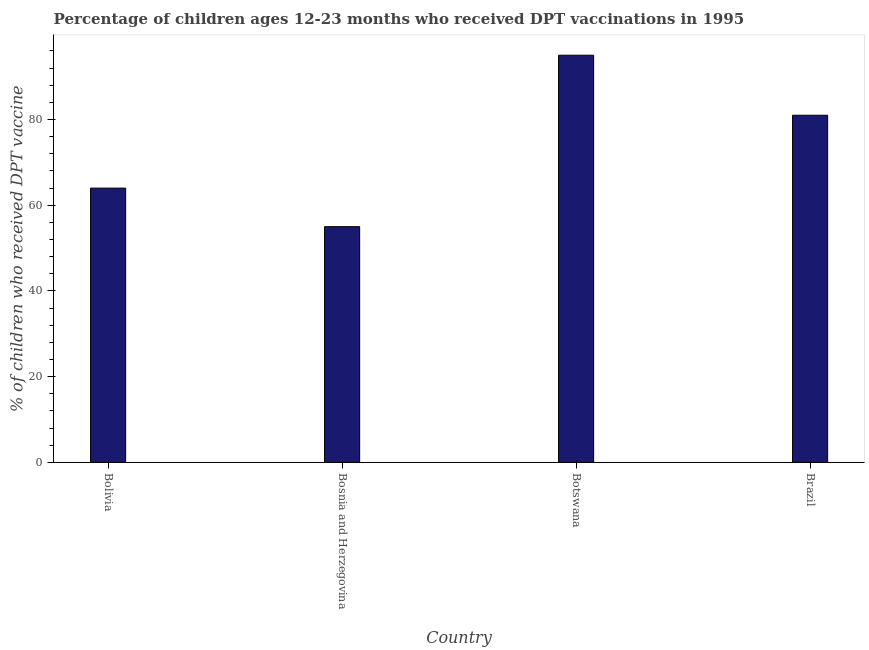What is the title of the graph?
Your answer should be compact. Percentage of children ages 12-23 months who received DPT vaccinations in 1995. What is the label or title of the X-axis?
Give a very brief answer. Country. What is the label or title of the Y-axis?
Ensure brevity in your answer.  % of children who received DPT vaccine. What is the percentage of children who received dpt vaccine in Bosnia and Herzegovina?
Your answer should be very brief. 55. Across all countries, what is the minimum percentage of children who received dpt vaccine?
Make the answer very short. 55. In which country was the percentage of children who received dpt vaccine maximum?
Offer a terse response. Botswana. In which country was the percentage of children who received dpt vaccine minimum?
Your answer should be very brief. Bosnia and Herzegovina. What is the sum of the percentage of children who received dpt vaccine?
Keep it short and to the point. 295. What is the difference between the percentage of children who received dpt vaccine in Bosnia and Herzegovina and Brazil?
Offer a terse response. -26. What is the average percentage of children who received dpt vaccine per country?
Provide a short and direct response. 73.75. What is the median percentage of children who received dpt vaccine?
Give a very brief answer. 72.5. What is the ratio of the percentage of children who received dpt vaccine in Bolivia to that in Bosnia and Herzegovina?
Give a very brief answer. 1.16. Is the difference between the percentage of children who received dpt vaccine in Bolivia and Botswana greater than the difference between any two countries?
Your answer should be compact. No. What is the difference between the highest and the second highest percentage of children who received dpt vaccine?
Offer a very short reply. 14. Is the sum of the percentage of children who received dpt vaccine in Bosnia and Herzegovina and Brazil greater than the maximum percentage of children who received dpt vaccine across all countries?
Ensure brevity in your answer.  Yes. What is the difference between the highest and the lowest percentage of children who received dpt vaccine?
Your answer should be very brief. 40. In how many countries, is the percentage of children who received dpt vaccine greater than the average percentage of children who received dpt vaccine taken over all countries?
Provide a succinct answer. 2. How many bars are there?
Your response must be concise. 4. Are all the bars in the graph horizontal?
Offer a very short reply. No. What is the difference between two consecutive major ticks on the Y-axis?
Ensure brevity in your answer.  20. What is the % of children who received DPT vaccine of Bolivia?
Your answer should be very brief. 64. What is the % of children who received DPT vaccine of Bosnia and Herzegovina?
Provide a succinct answer. 55. What is the % of children who received DPT vaccine of Brazil?
Your answer should be very brief. 81. What is the difference between the % of children who received DPT vaccine in Bolivia and Bosnia and Herzegovina?
Ensure brevity in your answer.  9. What is the difference between the % of children who received DPT vaccine in Bolivia and Botswana?
Keep it short and to the point. -31. What is the difference between the % of children who received DPT vaccine in Bolivia and Brazil?
Give a very brief answer. -17. What is the difference between the % of children who received DPT vaccine in Bosnia and Herzegovina and Brazil?
Make the answer very short. -26. What is the difference between the % of children who received DPT vaccine in Botswana and Brazil?
Ensure brevity in your answer.  14. What is the ratio of the % of children who received DPT vaccine in Bolivia to that in Bosnia and Herzegovina?
Offer a terse response. 1.16. What is the ratio of the % of children who received DPT vaccine in Bolivia to that in Botswana?
Keep it short and to the point. 0.67. What is the ratio of the % of children who received DPT vaccine in Bolivia to that in Brazil?
Offer a terse response. 0.79. What is the ratio of the % of children who received DPT vaccine in Bosnia and Herzegovina to that in Botswana?
Offer a very short reply. 0.58. What is the ratio of the % of children who received DPT vaccine in Bosnia and Herzegovina to that in Brazil?
Your response must be concise. 0.68. What is the ratio of the % of children who received DPT vaccine in Botswana to that in Brazil?
Provide a succinct answer. 1.17. 